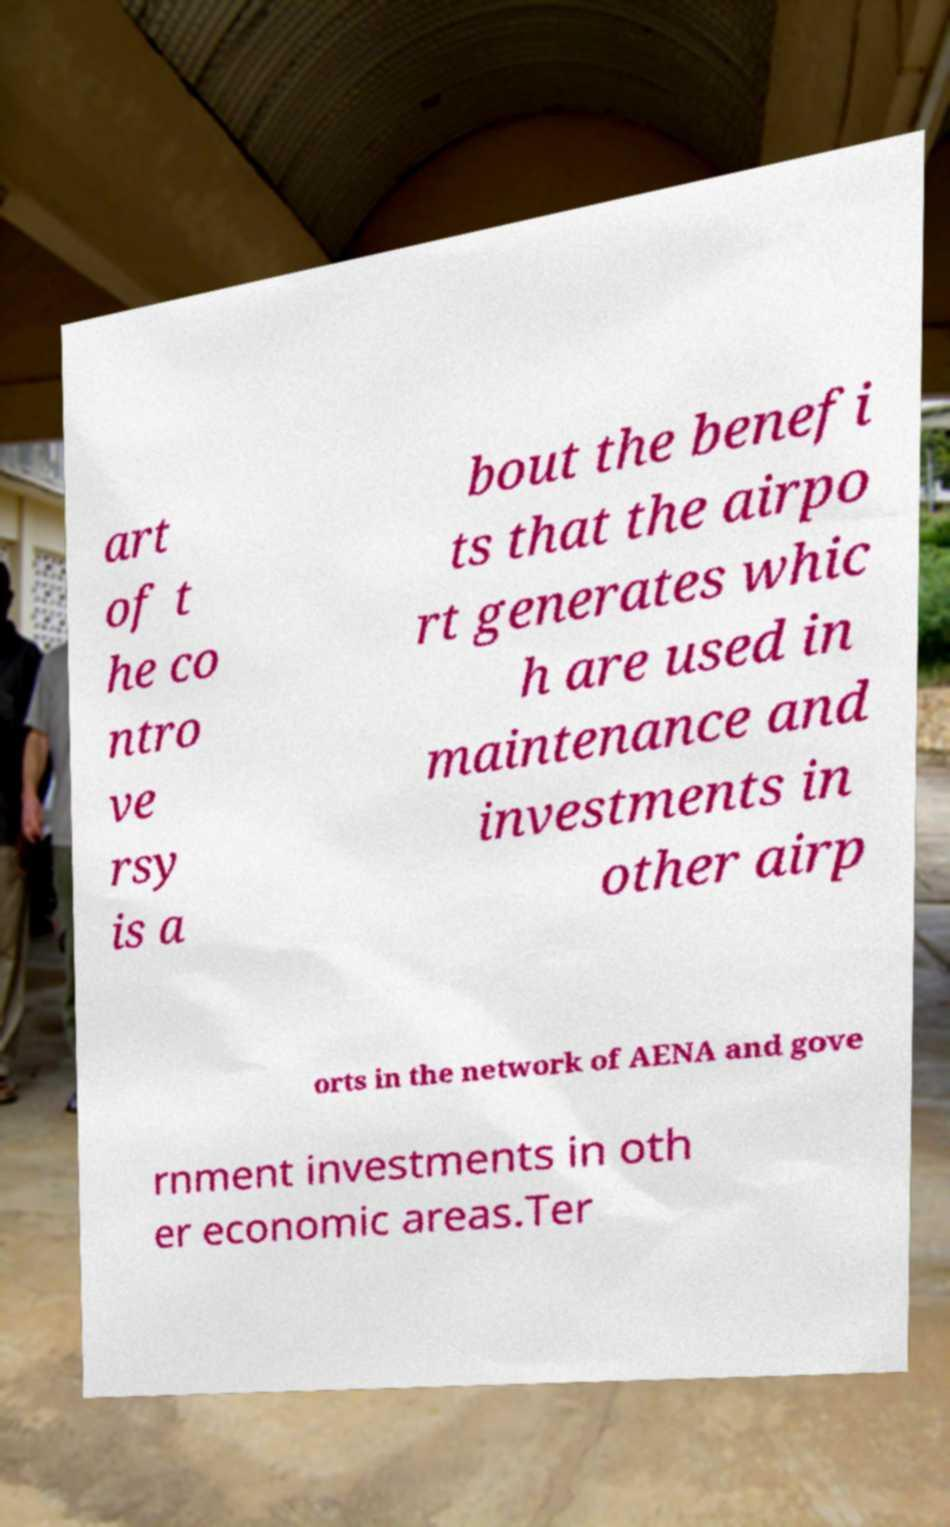There's text embedded in this image that I need extracted. Can you transcribe it verbatim? art of t he co ntro ve rsy is a bout the benefi ts that the airpo rt generates whic h are used in maintenance and investments in other airp orts in the network of AENA and gove rnment investments in oth er economic areas.Ter 